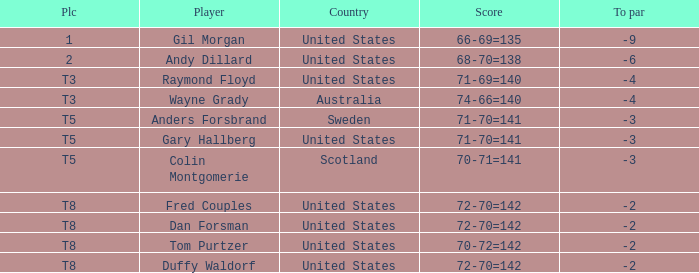What is the To par of the Player with a Score of 70-71=141? -3.0. Help me parse the entirety of this table. {'header': ['Plc', 'Player', 'Country', 'Score', 'To par'], 'rows': [['1', 'Gil Morgan', 'United States', '66-69=135', '-9'], ['2', 'Andy Dillard', 'United States', '68-70=138', '-6'], ['T3', 'Raymond Floyd', 'United States', '71-69=140', '-4'], ['T3', 'Wayne Grady', 'Australia', '74-66=140', '-4'], ['T5', 'Anders Forsbrand', 'Sweden', '71-70=141', '-3'], ['T5', 'Gary Hallberg', 'United States', '71-70=141', '-3'], ['T5', 'Colin Montgomerie', 'Scotland', '70-71=141', '-3'], ['T8', 'Fred Couples', 'United States', '72-70=142', '-2'], ['T8', 'Dan Forsman', 'United States', '72-70=142', '-2'], ['T8', 'Tom Purtzer', 'United States', '70-72=142', '-2'], ['T8', 'Duffy Waldorf', 'United States', '72-70=142', '-2']]} 